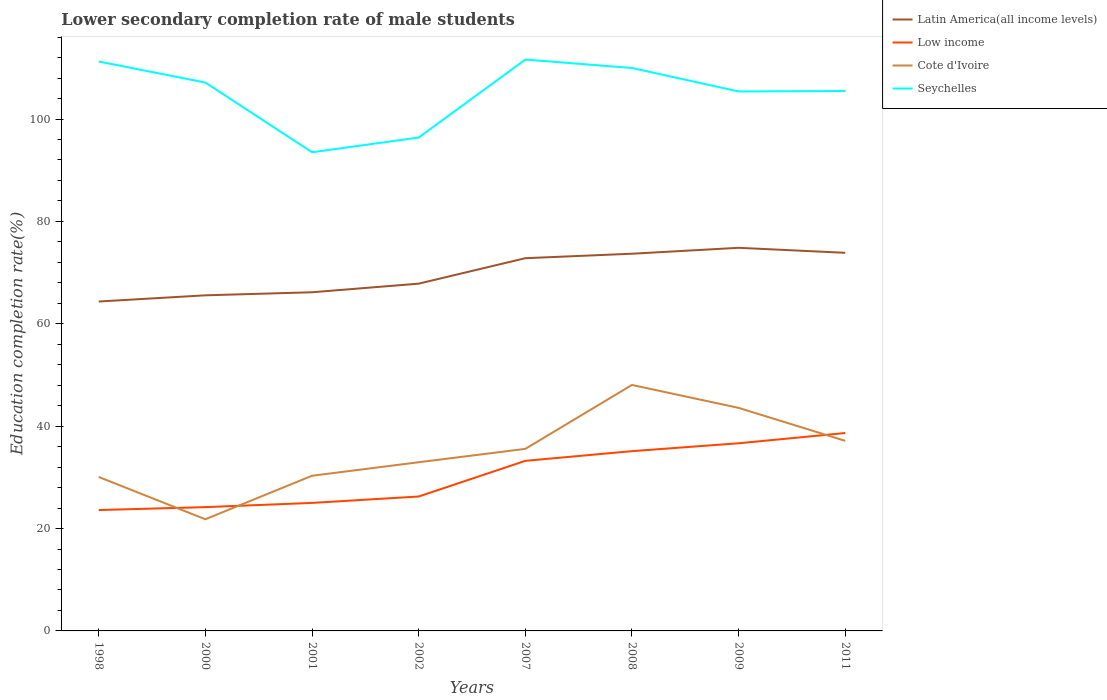How many different coloured lines are there?
Provide a succinct answer. 4. Does the line corresponding to Cote d'Ivoire intersect with the line corresponding to Low income?
Give a very brief answer. Yes. Across all years, what is the maximum lower secondary completion rate of male students in Low income?
Keep it short and to the point. 23.61. In which year was the lower secondary completion rate of male students in Low income maximum?
Your answer should be compact. 1998. What is the total lower secondary completion rate of male students in Low income in the graph?
Give a very brief answer. -6.97. What is the difference between the highest and the second highest lower secondary completion rate of male students in Seychelles?
Keep it short and to the point. 18.11. Where does the legend appear in the graph?
Your response must be concise. Top right. How many legend labels are there?
Offer a terse response. 4. How are the legend labels stacked?
Provide a succinct answer. Vertical. What is the title of the graph?
Ensure brevity in your answer.  Lower secondary completion rate of male students. What is the label or title of the Y-axis?
Ensure brevity in your answer.  Education completion rate(%). What is the Education completion rate(%) in Latin America(all income levels) in 1998?
Offer a terse response. 64.35. What is the Education completion rate(%) in Low income in 1998?
Your answer should be compact. 23.61. What is the Education completion rate(%) of Cote d'Ivoire in 1998?
Your response must be concise. 30.08. What is the Education completion rate(%) in Seychelles in 1998?
Offer a very short reply. 111.24. What is the Education completion rate(%) of Latin America(all income levels) in 2000?
Offer a very short reply. 65.56. What is the Education completion rate(%) of Low income in 2000?
Offer a very short reply. 24.18. What is the Education completion rate(%) in Cote d'Ivoire in 2000?
Offer a terse response. 21.82. What is the Education completion rate(%) of Seychelles in 2000?
Make the answer very short. 107.12. What is the Education completion rate(%) in Latin America(all income levels) in 2001?
Give a very brief answer. 66.16. What is the Education completion rate(%) in Low income in 2001?
Keep it short and to the point. 25.01. What is the Education completion rate(%) in Cote d'Ivoire in 2001?
Offer a terse response. 30.31. What is the Education completion rate(%) in Seychelles in 2001?
Make the answer very short. 93.51. What is the Education completion rate(%) of Latin America(all income levels) in 2002?
Make the answer very short. 67.84. What is the Education completion rate(%) in Low income in 2002?
Make the answer very short. 26.26. What is the Education completion rate(%) of Cote d'Ivoire in 2002?
Give a very brief answer. 32.95. What is the Education completion rate(%) in Seychelles in 2002?
Offer a terse response. 96.39. What is the Education completion rate(%) of Latin America(all income levels) in 2007?
Provide a short and direct response. 72.81. What is the Education completion rate(%) of Low income in 2007?
Offer a terse response. 33.23. What is the Education completion rate(%) of Cote d'Ivoire in 2007?
Your answer should be very brief. 35.57. What is the Education completion rate(%) in Seychelles in 2007?
Your answer should be compact. 111.62. What is the Education completion rate(%) of Latin America(all income levels) in 2008?
Provide a succinct answer. 73.69. What is the Education completion rate(%) in Low income in 2008?
Ensure brevity in your answer.  35.12. What is the Education completion rate(%) of Cote d'Ivoire in 2008?
Your answer should be compact. 48.05. What is the Education completion rate(%) in Seychelles in 2008?
Ensure brevity in your answer.  109.97. What is the Education completion rate(%) of Latin America(all income levels) in 2009?
Keep it short and to the point. 74.85. What is the Education completion rate(%) of Low income in 2009?
Ensure brevity in your answer.  36.66. What is the Education completion rate(%) in Cote d'Ivoire in 2009?
Make the answer very short. 43.58. What is the Education completion rate(%) in Seychelles in 2009?
Your answer should be very brief. 105.39. What is the Education completion rate(%) of Latin America(all income levels) in 2011?
Provide a short and direct response. 73.87. What is the Education completion rate(%) in Low income in 2011?
Make the answer very short. 38.66. What is the Education completion rate(%) of Cote d'Ivoire in 2011?
Provide a short and direct response. 37.13. What is the Education completion rate(%) of Seychelles in 2011?
Your answer should be compact. 105.48. Across all years, what is the maximum Education completion rate(%) in Latin America(all income levels)?
Give a very brief answer. 74.85. Across all years, what is the maximum Education completion rate(%) in Low income?
Make the answer very short. 38.66. Across all years, what is the maximum Education completion rate(%) in Cote d'Ivoire?
Offer a terse response. 48.05. Across all years, what is the maximum Education completion rate(%) in Seychelles?
Ensure brevity in your answer.  111.62. Across all years, what is the minimum Education completion rate(%) in Latin America(all income levels)?
Provide a short and direct response. 64.35. Across all years, what is the minimum Education completion rate(%) of Low income?
Ensure brevity in your answer.  23.61. Across all years, what is the minimum Education completion rate(%) in Cote d'Ivoire?
Provide a short and direct response. 21.82. Across all years, what is the minimum Education completion rate(%) of Seychelles?
Your answer should be compact. 93.51. What is the total Education completion rate(%) in Latin America(all income levels) in the graph?
Provide a short and direct response. 559.14. What is the total Education completion rate(%) of Low income in the graph?
Your answer should be compact. 242.74. What is the total Education completion rate(%) of Cote d'Ivoire in the graph?
Make the answer very short. 279.49. What is the total Education completion rate(%) of Seychelles in the graph?
Keep it short and to the point. 840.73. What is the difference between the Education completion rate(%) in Latin America(all income levels) in 1998 and that in 2000?
Provide a succinct answer. -1.21. What is the difference between the Education completion rate(%) in Low income in 1998 and that in 2000?
Your answer should be very brief. -0.57. What is the difference between the Education completion rate(%) in Cote d'Ivoire in 1998 and that in 2000?
Ensure brevity in your answer.  8.26. What is the difference between the Education completion rate(%) in Seychelles in 1998 and that in 2000?
Your answer should be compact. 4.12. What is the difference between the Education completion rate(%) in Latin America(all income levels) in 1998 and that in 2001?
Your answer should be compact. -1.81. What is the difference between the Education completion rate(%) in Low income in 1998 and that in 2001?
Keep it short and to the point. -1.4. What is the difference between the Education completion rate(%) in Cote d'Ivoire in 1998 and that in 2001?
Offer a very short reply. -0.24. What is the difference between the Education completion rate(%) of Seychelles in 1998 and that in 2001?
Your answer should be compact. 17.73. What is the difference between the Education completion rate(%) in Latin America(all income levels) in 1998 and that in 2002?
Give a very brief answer. -3.49. What is the difference between the Education completion rate(%) in Low income in 1998 and that in 2002?
Your answer should be compact. -2.64. What is the difference between the Education completion rate(%) of Cote d'Ivoire in 1998 and that in 2002?
Ensure brevity in your answer.  -2.88. What is the difference between the Education completion rate(%) of Seychelles in 1998 and that in 2002?
Make the answer very short. 14.85. What is the difference between the Education completion rate(%) in Latin America(all income levels) in 1998 and that in 2007?
Offer a very short reply. -8.46. What is the difference between the Education completion rate(%) of Low income in 1998 and that in 2007?
Provide a short and direct response. -9.61. What is the difference between the Education completion rate(%) of Cote d'Ivoire in 1998 and that in 2007?
Make the answer very short. -5.49. What is the difference between the Education completion rate(%) in Seychelles in 1998 and that in 2007?
Your response must be concise. -0.38. What is the difference between the Education completion rate(%) in Latin America(all income levels) in 1998 and that in 2008?
Your response must be concise. -9.34. What is the difference between the Education completion rate(%) of Low income in 1998 and that in 2008?
Keep it short and to the point. -11.5. What is the difference between the Education completion rate(%) in Cote d'Ivoire in 1998 and that in 2008?
Provide a succinct answer. -17.97. What is the difference between the Education completion rate(%) in Seychelles in 1998 and that in 2008?
Make the answer very short. 1.27. What is the difference between the Education completion rate(%) in Latin America(all income levels) in 1998 and that in 2009?
Offer a terse response. -10.49. What is the difference between the Education completion rate(%) of Low income in 1998 and that in 2009?
Ensure brevity in your answer.  -13.05. What is the difference between the Education completion rate(%) in Cote d'Ivoire in 1998 and that in 2009?
Your answer should be very brief. -13.5. What is the difference between the Education completion rate(%) in Seychelles in 1998 and that in 2009?
Provide a succinct answer. 5.85. What is the difference between the Education completion rate(%) of Latin America(all income levels) in 1998 and that in 2011?
Provide a short and direct response. -9.51. What is the difference between the Education completion rate(%) in Low income in 1998 and that in 2011?
Give a very brief answer. -15.05. What is the difference between the Education completion rate(%) of Cote d'Ivoire in 1998 and that in 2011?
Provide a succinct answer. -7.05. What is the difference between the Education completion rate(%) of Seychelles in 1998 and that in 2011?
Your response must be concise. 5.76. What is the difference between the Education completion rate(%) of Latin America(all income levels) in 2000 and that in 2001?
Provide a succinct answer. -0.6. What is the difference between the Education completion rate(%) in Low income in 2000 and that in 2001?
Your response must be concise. -0.83. What is the difference between the Education completion rate(%) in Cote d'Ivoire in 2000 and that in 2001?
Give a very brief answer. -8.5. What is the difference between the Education completion rate(%) of Seychelles in 2000 and that in 2001?
Offer a terse response. 13.61. What is the difference between the Education completion rate(%) of Latin America(all income levels) in 2000 and that in 2002?
Your response must be concise. -2.28. What is the difference between the Education completion rate(%) in Low income in 2000 and that in 2002?
Provide a succinct answer. -2.07. What is the difference between the Education completion rate(%) in Cote d'Ivoire in 2000 and that in 2002?
Keep it short and to the point. -11.14. What is the difference between the Education completion rate(%) of Seychelles in 2000 and that in 2002?
Your answer should be compact. 10.73. What is the difference between the Education completion rate(%) in Latin America(all income levels) in 2000 and that in 2007?
Give a very brief answer. -7.25. What is the difference between the Education completion rate(%) in Low income in 2000 and that in 2007?
Keep it short and to the point. -9.04. What is the difference between the Education completion rate(%) in Cote d'Ivoire in 2000 and that in 2007?
Your answer should be compact. -13.75. What is the difference between the Education completion rate(%) of Seychelles in 2000 and that in 2007?
Your answer should be compact. -4.5. What is the difference between the Education completion rate(%) of Latin America(all income levels) in 2000 and that in 2008?
Your answer should be very brief. -8.13. What is the difference between the Education completion rate(%) of Low income in 2000 and that in 2008?
Offer a very short reply. -10.93. What is the difference between the Education completion rate(%) in Cote d'Ivoire in 2000 and that in 2008?
Offer a very short reply. -26.24. What is the difference between the Education completion rate(%) of Seychelles in 2000 and that in 2008?
Your response must be concise. -2.85. What is the difference between the Education completion rate(%) of Latin America(all income levels) in 2000 and that in 2009?
Provide a short and direct response. -9.28. What is the difference between the Education completion rate(%) of Low income in 2000 and that in 2009?
Give a very brief answer. -12.48. What is the difference between the Education completion rate(%) of Cote d'Ivoire in 2000 and that in 2009?
Keep it short and to the point. -21.76. What is the difference between the Education completion rate(%) of Seychelles in 2000 and that in 2009?
Give a very brief answer. 1.73. What is the difference between the Education completion rate(%) of Latin America(all income levels) in 2000 and that in 2011?
Your answer should be compact. -8.3. What is the difference between the Education completion rate(%) of Low income in 2000 and that in 2011?
Give a very brief answer. -14.48. What is the difference between the Education completion rate(%) of Cote d'Ivoire in 2000 and that in 2011?
Offer a terse response. -15.32. What is the difference between the Education completion rate(%) of Seychelles in 2000 and that in 2011?
Provide a short and direct response. 1.65. What is the difference between the Education completion rate(%) in Latin America(all income levels) in 2001 and that in 2002?
Your answer should be very brief. -1.68. What is the difference between the Education completion rate(%) of Low income in 2001 and that in 2002?
Give a very brief answer. -1.25. What is the difference between the Education completion rate(%) of Cote d'Ivoire in 2001 and that in 2002?
Provide a succinct answer. -2.64. What is the difference between the Education completion rate(%) in Seychelles in 2001 and that in 2002?
Offer a terse response. -2.88. What is the difference between the Education completion rate(%) in Latin America(all income levels) in 2001 and that in 2007?
Your response must be concise. -6.66. What is the difference between the Education completion rate(%) of Low income in 2001 and that in 2007?
Your answer should be compact. -8.22. What is the difference between the Education completion rate(%) of Cote d'Ivoire in 2001 and that in 2007?
Provide a short and direct response. -5.25. What is the difference between the Education completion rate(%) in Seychelles in 2001 and that in 2007?
Make the answer very short. -18.11. What is the difference between the Education completion rate(%) in Latin America(all income levels) in 2001 and that in 2008?
Make the answer very short. -7.53. What is the difference between the Education completion rate(%) of Low income in 2001 and that in 2008?
Provide a short and direct response. -10.11. What is the difference between the Education completion rate(%) of Cote d'Ivoire in 2001 and that in 2008?
Offer a terse response. -17.74. What is the difference between the Education completion rate(%) in Seychelles in 2001 and that in 2008?
Give a very brief answer. -16.46. What is the difference between the Education completion rate(%) of Latin America(all income levels) in 2001 and that in 2009?
Offer a very short reply. -8.69. What is the difference between the Education completion rate(%) of Low income in 2001 and that in 2009?
Keep it short and to the point. -11.65. What is the difference between the Education completion rate(%) in Cote d'Ivoire in 2001 and that in 2009?
Ensure brevity in your answer.  -13.26. What is the difference between the Education completion rate(%) of Seychelles in 2001 and that in 2009?
Give a very brief answer. -11.88. What is the difference between the Education completion rate(%) in Latin America(all income levels) in 2001 and that in 2011?
Offer a terse response. -7.71. What is the difference between the Education completion rate(%) in Low income in 2001 and that in 2011?
Ensure brevity in your answer.  -13.65. What is the difference between the Education completion rate(%) of Cote d'Ivoire in 2001 and that in 2011?
Give a very brief answer. -6.82. What is the difference between the Education completion rate(%) of Seychelles in 2001 and that in 2011?
Give a very brief answer. -11.97. What is the difference between the Education completion rate(%) in Latin America(all income levels) in 2002 and that in 2007?
Ensure brevity in your answer.  -4.97. What is the difference between the Education completion rate(%) in Low income in 2002 and that in 2007?
Offer a terse response. -6.97. What is the difference between the Education completion rate(%) of Cote d'Ivoire in 2002 and that in 2007?
Keep it short and to the point. -2.61. What is the difference between the Education completion rate(%) of Seychelles in 2002 and that in 2007?
Provide a succinct answer. -15.23. What is the difference between the Education completion rate(%) in Latin America(all income levels) in 2002 and that in 2008?
Offer a terse response. -5.85. What is the difference between the Education completion rate(%) in Low income in 2002 and that in 2008?
Provide a short and direct response. -8.86. What is the difference between the Education completion rate(%) of Cote d'Ivoire in 2002 and that in 2008?
Your answer should be very brief. -15.1. What is the difference between the Education completion rate(%) of Seychelles in 2002 and that in 2008?
Provide a short and direct response. -13.58. What is the difference between the Education completion rate(%) in Latin America(all income levels) in 2002 and that in 2009?
Offer a very short reply. -7. What is the difference between the Education completion rate(%) of Low income in 2002 and that in 2009?
Your answer should be compact. -10.4. What is the difference between the Education completion rate(%) in Cote d'Ivoire in 2002 and that in 2009?
Ensure brevity in your answer.  -10.62. What is the difference between the Education completion rate(%) in Seychelles in 2002 and that in 2009?
Offer a terse response. -9. What is the difference between the Education completion rate(%) of Latin America(all income levels) in 2002 and that in 2011?
Provide a short and direct response. -6.02. What is the difference between the Education completion rate(%) of Low income in 2002 and that in 2011?
Ensure brevity in your answer.  -12.4. What is the difference between the Education completion rate(%) of Cote d'Ivoire in 2002 and that in 2011?
Give a very brief answer. -4.18. What is the difference between the Education completion rate(%) in Seychelles in 2002 and that in 2011?
Keep it short and to the point. -9.09. What is the difference between the Education completion rate(%) of Latin America(all income levels) in 2007 and that in 2008?
Your answer should be very brief. -0.88. What is the difference between the Education completion rate(%) of Low income in 2007 and that in 2008?
Your answer should be compact. -1.89. What is the difference between the Education completion rate(%) of Cote d'Ivoire in 2007 and that in 2008?
Your response must be concise. -12.48. What is the difference between the Education completion rate(%) in Seychelles in 2007 and that in 2008?
Offer a terse response. 1.65. What is the difference between the Education completion rate(%) of Latin America(all income levels) in 2007 and that in 2009?
Provide a short and direct response. -2.03. What is the difference between the Education completion rate(%) of Low income in 2007 and that in 2009?
Make the answer very short. -3.43. What is the difference between the Education completion rate(%) in Cote d'Ivoire in 2007 and that in 2009?
Make the answer very short. -8.01. What is the difference between the Education completion rate(%) of Seychelles in 2007 and that in 2009?
Make the answer very short. 6.23. What is the difference between the Education completion rate(%) of Latin America(all income levels) in 2007 and that in 2011?
Provide a short and direct response. -1.05. What is the difference between the Education completion rate(%) in Low income in 2007 and that in 2011?
Your answer should be compact. -5.43. What is the difference between the Education completion rate(%) of Cote d'Ivoire in 2007 and that in 2011?
Give a very brief answer. -1.56. What is the difference between the Education completion rate(%) of Seychelles in 2007 and that in 2011?
Give a very brief answer. 6.14. What is the difference between the Education completion rate(%) of Latin America(all income levels) in 2008 and that in 2009?
Ensure brevity in your answer.  -1.16. What is the difference between the Education completion rate(%) in Low income in 2008 and that in 2009?
Provide a succinct answer. -1.54. What is the difference between the Education completion rate(%) of Cote d'Ivoire in 2008 and that in 2009?
Make the answer very short. 4.48. What is the difference between the Education completion rate(%) in Seychelles in 2008 and that in 2009?
Give a very brief answer. 4.58. What is the difference between the Education completion rate(%) of Latin America(all income levels) in 2008 and that in 2011?
Your answer should be compact. -0.18. What is the difference between the Education completion rate(%) of Low income in 2008 and that in 2011?
Offer a very short reply. -3.54. What is the difference between the Education completion rate(%) of Cote d'Ivoire in 2008 and that in 2011?
Provide a short and direct response. 10.92. What is the difference between the Education completion rate(%) in Seychelles in 2008 and that in 2011?
Provide a short and direct response. 4.49. What is the difference between the Education completion rate(%) of Latin America(all income levels) in 2009 and that in 2011?
Offer a very short reply. 0.98. What is the difference between the Education completion rate(%) of Low income in 2009 and that in 2011?
Provide a short and direct response. -2. What is the difference between the Education completion rate(%) of Cote d'Ivoire in 2009 and that in 2011?
Your answer should be very brief. 6.44. What is the difference between the Education completion rate(%) of Seychelles in 2009 and that in 2011?
Offer a very short reply. -0.09. What is the difference between the Education completion rate(%) in Latin America(all income levels) in 1998 and the Education completion rate(%) in Low income in 2000?
Keep it short and to the point. 40.17. What is the difference between the Education completion rate(%) of Latin America(all income levels) in 1998 and the Education completion rate(%) of Cote d'Ivoire in 2000?
Give a very brief answer. 42.54. What is the difference between the Education completion rate(%) in Latin America(all income levels) in 1998 and the Education completion rate(%) in Seychelles in 2000?
Make the answer very short. -42.77. What is the difference between the Education completion rate(%) in Low income in 1998 and the Education completion rate(%) in Cote d'Ivoire in 2000?
Provide a short and direct response. 1.8. What is the difference between the Education completion rate(%) of Low income in 1998 and the Education completion rate(%) of Seychelles in 2000?
Offer a very short reply. -83.51. What is the difference between the Education completion rate(%) in Cote d'Ivoire in 1998 and the Education completion rate(%) in Seychelles in 2000?
Give a very brief answer. -77.05. What is the difference between the Education completion rate(%) in Latin America(all income levels) in 1998 and the Education completion rate(%) in Low income in 2001?
Give a very brief answer. 39.34. What is the difference between the Education completion rate(%) in Latin America(all income levels) in 1998 and the Education completion rate(%) in Cote d'Ivoire in 2001?
Give a very brief answer. 34.04. What is the difference between the Education completion rate(%) in Latin America(all income levels) in 1998 and the Education completion rate(%) in Seychelles in 2001?
Provide a short and direct response. -29.16. What is the difference between the Education completion rate(%) in Low income in 1998 and the Education completion rate(%) in Cote d'Ivoire in 2001?
Ensure brevity in your answer.  -6.7. What is the difference between the Education completion rate(%) in Low income in 1998 and the Education completion rate(%) in Seychelles in 2001?
Your answer should be compact. -69.9. What is the difference between the Education completion rate(%) of Cote d'Ivoire in 1998 and the Education completion rate(%) of Seychelles in 2001?
Provide a succinct answer. -63.43. What is the difference between the Education completion rate(%) of Latin America(all income levels) in 1998 and the Education completion rate(%) of Low income in 2002?
Offer a very short reply. 38.1. What is the difference between the Education completion rate(%) in Latin America(all income levels) in 1998 and the Education completion rate(%) in Cote d'Ivoire in 2002?
Provide a short and direct response. 31.4. What is the difference between the Education completion rate(%) in Latin America(all income levels) in 1998 and the Education completion rate(%) in Seychelles in 2002?
Your answer should be very brief. -32.04. What is the difference between the Education completion rate(%) in Low income in 1998 and the Education completion rate(%) in Cote d'Ivoire in 2002?
Keep it short and to the point. -9.34. What is the difference between the Education completion rate(%) in Low income in 1998 and the Education completion rate(%) in Seychelles in 2002?
Offer a very short reply. -72.78. What is the difference between the Education completion rate(%) of Cote d'Ivoire in 1998 and the Education completion rate(%) of Seychelles in 2002?
Your answer should be very brief. -66.31. What is the difference between the Education completion rate(%) in Latin America(all income levels) in 1998 and the Education completion rate(%) in Low income in 2007?
Offer a terse response. 31.13. What is the difference between the Education completion rate(%) in Latin America(all income levels) in 1998 and the Education completion rate(%) in Cote d'Ivoire in 2007?
Your answer should be very brief. 28.79. What is the difference between the Education completion rate(%) of Latin America(all income levels) in 1998 and the Education completion rate(%) of Seychelles in 2007?
Offer a terse response. -47.27. What is the difference between the Education completion rate(%) in Low income in 1998 and the Education completion rate(%) in Cote d'Ivoire in 2007?
Provide a short and direct response. -11.95. What is the difference between the Education completion rate(%) in Low income in 1998 and the Education completion rate(%) in Seychelles in 2007?
Your answer should be very brief. -88.01. What is the difference between the Education completion rate(%) of Cote d'Ivoire in 1998 and the Education completion rate(%) of Seychelles in 2007?
Offer a very short reply. -81.54. What is the difference between the Education completion rate(%) of Latin America(all income levels) in 1998 and the Education completion rate(%) of Low income in 2008?
Provide a short and direct response. 29.24. What is the difference between the Education completion rate(%) of Latin America(all income levels) in 1998 and the Education completion rate(%) of Cote d'Ivoire in 2008?
Provide a succinct answer. 16.3. What is the difference between the Education completion rate(%) of Latin America(all income levels) in 1998 and the Education completion rate(%) of Seychelles in 2008?
Your response must be concise. -45.62. What is the difference between the Education completion rate(%) in Low income in 1998 and the Education completion rate(%) in Cote d'Ivoire in 2008?
Your answer should be compact. -24.44. What is the difference between the Education completion rate(%) of Low income in 1998 and the Education completion rate(%) of Seychelles in 2008?
Offer a terse response. -86.36. What is the difference between the Education completion rate(%) in Cote d'Ivoire in 1998 and the Education completion rate(%) in Seychelles in 2008?
Your answer should be very brief. -79.89. What is the difference between the Education completion rate(%) in Latin America(all income levels) in 1998 and the Education completion rate(%) in Low income in 2009?
Offer a very short reply. 27.69. What is the difference between the Education completion rate(%) of Latin America(all income levels) in 1998 and the Education completion rate(%) of Cote d'Ivoire in 2009?
Give a very brief answer. 20.78. What is the difference between the Education completion rate(%) of Latin America(all income levels) in 1998 and the Education completion rate(%) of Seychelles in 2009?
Keep it short and to the point. -41.04. What is the difference between the Education completion rate(%) of Low income in 1998 and the Education completion rate(%) of Cote d'Ivoire in 2009?
Provide a short and direct response. -19.96. What is the difference between the Education completion rate(%) in Low income in 1998 and the Education completion rate(%) in Seychelles in 2009?
Ensure brevity in your answer.  -81.78. What is the difference between the Education completion rate(%) of Cote d'Ivoire in 1998 and the Education completion rate(%) of Seychelles in 2009?
Offer a terse response. -75.31. What is the difference between the Education completion rate(%) in Latin America(all income levels) in 1998 and the Education completion rate(%) in Low income in 2011?
Provide a short and direct response. 25.69. What is the difference between the Education completion rate(%) in Latin America(all income levels) in 1998 and the Education completion rate(%) in Cote d'Ivoire in 2011?
Your answer should be compact. 27.22. What is the difference between the Education completion rate(%) of Latin America(all income levels) in 1998 and the Education completion rate(%) of Seychelles in 2011?
Provide a succinct answer. -41.13. What is the difference between the Education completion rate(%) of Low income in 1998 and the Education completion rate(%) of Cote d'Ivoire in 2011?
Offer a very short reply. -13.52. What is the difference between the Education completion rate(%) in Low income in 1998 and the Education completion rate(%) in Seychelles in 2011?
Make the answer very short. -81.86. What is the difference between the Education completion rate(%) in Cote d'Ivoire in 1998 and the Education completion rate(%) in Seychelles in 2011?
Ensure brevity in your answer.  -75.4. What is the difference between the Education completion rate(%) of Latin America(all income levels) in 2000 and the Education completion rate(%) of Low income in 2001?
Your answer should be compact. 40.55. What is the difference between the Education completion rate(%) of Latin America(all income levels) in 2000 and the Education completion rate(%) of Cote d'Ivoire in 2001?
Provide a short and direct response. 35.25. What is the difference between the Education completion rate(%) in Latin America(all income levels) in 2000 and the Education completion rate(%) in Seychelles in 2001?
Your answer should be very brief. -27.95. What is the difference between the Education completion rate(%) of Low income in 2000 and the Education completion rate(%) of Cote d'Ivoire in 2001?
Your answer should be very brief. -6.13. What is the difference between the Education completion rate(%) in Low income in 2000 and the Education completion rate(%) in Seychelles in 2001?
Provide a short and direct response. -69.33. What is the difference between the Education completion rate(%) of Cote d'Ivoire in 2000 and the Education completion rate(%) of Seychelles in 2001?
Your answer should be very brief. -71.7. What is the difference between the Education completion rate(%) of Latin America(all income levels) in 2000 and the Education completion rate(%) of Low income in 2002?
Keep it short and to the point. 39.31. What is the difference between the Education completion rate(%) in Latin America(all income levels) in 2000 and the Education completion rate(%) in Cote d'Ivoire in 2002?
Provide a short and direct response. 32.61. What is the difference between the Education completion rate(%) in Latin America(all income levels) in 2000 and the Education completion rate(%) in Seychelles in 2002?
Provide a succinct answer. -30.83. What is the difference between the Education completion rate(%) in Low income in 2000 and the Education completion rate(%) in Cote d'Ivoire in 2002?
Give a very brief answer. -8.77. What is the difference between the Education completion rate(%) of Low income in 2000 and the Education completion rate(%) of Seychelles in 2002?
Offer a very short reply. -72.21. What is the difference between the Education completion rate(%) in Cote d'Ivoire in 2000 and the Education completion rate(%) in Seychelles in 2002?
Provide a succinct answer. -74.58. What is the difference between the Education completion rate(%) of Latin America(all income levels) in 2000 and the Education completion rate(%) of Low income in 2007?
Make the answer very short. 32.33. What is the difference between the Education completion rate(%) of Latin America(all income levels) in 2000 and the Education completion rate(%) of Cote d'Ivoire in 2007?
Offer a very short reply. 30. What is the difference between the Education completion rate(%) of Latin America(all income levels) in 2000 and the Education completion rate(%) of Seychelles in 2007?
Ensure brevity in your answer.  -46.06. What is the difference between the Education completion rate(%) of Low income in 2000 and the Education completion rate(%) of Cote d'Ivoire in 2007?
Keep it short and to the point. -11.38. What is the difference between the Education completion rate(%) of Low income in 2000 and the Education completion rate(%) of Seychelles in 2007?
Your answer should be compact. -87.44. What is the difference between the Education completion rate(%) of Cote d'Ivoire in 2000 and the Education completion rate(%) of Seychelles in 2007?
Keep it short and to the point. -89.81. What is the difference between the Education completion rate(%) of Latin America(all income levels) in 2000 and the Education completion rate(%) of Low income in 2008?
Offer a terse response. 30.44. What is the difference between the Education completion rate(%) of Latin America(all income levels) in 2000 and the Education completion rate(%) of Cote d'Ivoire in 2008?
Make the answer very short. 17.51. What is the difference between the Education completion rate(%) in Latin America(all income levels) in 2000 and the Education completion rate(%) in Seychelles in 2008?
Your answer should be very brief. -44.41. What is the difference between the Education completion rate(%) of Low income in 2000 and the Education completion rate(%) of Cote d'Ivoire in 2008?
Provide a short and direct response. -23.87. What is the difference between the Education completion rate(%) in Low income in 2000 and the Education completion rate(%) in Seychelles in 2008?
Provide a short and direct response. -85.79. What is the difference between the Education completion rate(%) of Cote d'Ivoire in 2000 and the Education completion rate(%) of Seychelles in 2008?
Ensure brevity in your answer.  -88.16. What is the difference between the Education completion rate(%) of Latin America(all income levels) in 2000 and the Education completion rate(%) of Low income in 2009?
Give a very brief answer. 28.9. What is the difference between the Education completion rate(%) of Latin America(all income levels) in 2000 and the Education completion rate(%) of Cote d'Ivoire in 2009?
Ensure brevity in your answer.  21.99. What is the difference between the Education completion rate(%) in Latin America(all income levels) in 2000 and the Education completion rate(%) in Seychelles in 2009?
Provide a short and direct response. -39.83. What is the difference between the Education completion rate(%) in Low income in 2000 and the Education completion rate(%) in Cote d'Ivoire in 2009?
Make the answer very short. -19.39. What is the difference between the Education completion rate(%) in Low income in 2000 and the Education completion rate(%) in Seychelles in 2009?
Keep it short and to the point. -81.21. What is the difference between the Education completion rate(%) of Cote d'Ivoire in 2000 and the Education completion rate(%) of Seychelles in 2009?
Give a very brief answer. -83.57. What is the difference between the Education completion rate(%) of Latin America(all income levels) in 2000 and the Education completion rate(%) of Low income in 2011?
Your response must be concise. 26.9. What is the difference between the Education completion rate(%) of Latin America(all income levels) in 2000 and the Education completion rate(%) of Cote d'Ivoire in 2011?
Offer a terse response. 28.43. What is the difference between the Education completion rate(%) in Latin America(all income levels) in 2000 and the Education completion rate(%) in Seychelles in 2011?
Give a very brief answer. -39.92. What is the difference between the Education completion rate(%) of Low income in 2000 and the Education completion rate(%) of Cote d'Ivoire in 2011?
Your answer should be compact. -12.95. What is the difference between the Education completion rate(%) of Low income in 2000 and the Education completion rate(%) of Seychelles in 2011?
Your answer should be very brief. -81.3. What is the difference between the Education completion rate(%) of Cote d'Ivoire in 2000 and the Education completion rate(%) of Seychelles in 2011?
Provide a succinct answer. -83.66. What is the difference between the Education completion rate(%) of Latin America(all income levels) in 2001 and the Education completion rate(%) of Low income in 2002?
Your answer should be very brief. 39.9. What is the difference between the Education completion rate(%) in Latin America(all income levels) in 2001 and the Education completion rate(%) in Cote d'Ivoire in 2002?
Your answer should be compact. 33.21. What is the difference between the Education completion rate(%) of Latin America(all income levels) in 2001 and the Education completion rate(%) of Seychelles in 2002?
Your response must be concise. -30.23. What is the difference between the Education completion rate(%) of Low income in 2001 and the Education completion rate(%) of Cote d'Ivoire in 2002?
Make the answer very short. -7.94. What is the difference between the Education completion rate(%) of Low income in 2001 and the Education completion rate(%) of Seychelles in 2002?
Make the answer very short. -71.38. What is the difference between the Education completion rate(%) in Cote d'Ivoire in 2001 and the Education completion rate(%) in Seychelles in 2002?
Provide a succinct answer. -66.08. What is the difference between the Education completion rate(%) of Latin America(all income levels) in 2001 and the Education completion rate(%) of Low income in 2007?
Your answer should be very brief. 32.93. What is the difference between the Education completion rate(%) in Latin America(all income levels) in 2001 and the Education completion rate(%) in Cote d'Ivoire in 2007?
Give a very brief answer. 30.59. What is the difference between the Education completion rate(%) in Latin America(all income levels) in 2001 and the Education completion rate(%) in Seychelles in 2007?
Give a very brief answer. -45.46. What is the difference between the Education completion rate(%) of Low income in 2001 and the Education completion rate(%) of Cote d'Ivoire in 2007?
Offer a very short reply. -10.56. What is the difference between the Education completion rate(%) in Low income in 2001 and the Education completion rate(%) in Seychelles in 2007?
Provide a short and direct response. -86.61. What is the difference between the Education completion rate(%) of Cote d'Ivoire in 2001 and the Education completion rate(%) of Seychelles in 2007?
Give a very brief answer. -81.31. What is the difference between the Education completion rate(%) in Latin America(all income levels) in 2001 and the Education completion rate(%) in Low income in 2008?
Ensure brevity in your answer.  31.04. What is the difference between the Education completion rate(%) in Latin America(all income levels) in 2001 and the Education completion rate(%) in Cote d'Ivoire in 2008?
Provide a short and direct response. 18.11. What is the difference between the Education completion rate(%) of Latin America(all income levels) in 2001 and the Education completion rate(%) of Seychelles in 2008?
Your answer should be very brief. -43.81. What is the difference between the Education completion rate(%) of Low income in 2001 and the Education completion rate(%) of Cote d'Ivoire in 2008?
Give a very brief answer. -23.04. What is the difference between the Education completion rate(%) of Low income in 2001 and the Education completion rate(%) of Seychelles in 2008?
Give a very brief answer. -84.96. What is the difference between the Education completion rate(%) of Cote d'Ivoire in 2001 and the Education completion rate(%) of Seychelles in 2008?
Provide a succinct answer. -79.66. What is the difference between the Education completion rate(%) of Latin America(all income levels) in 2001 and the Education completion rate(%) of Low income in 2009?
Your answer should be compact. 29.5. What is the difference between the Education completion rate(%) in Latin America(all income levels) in 2001 and the Education completion rate(%) in Cote d'Ivoire in 2009?
Offer a very short reply. 22.58. What is the difference between the Education completion rate(%) of Latin America(all income levels) in 2001 and the Education completion rate(%) of Seychelles in 2009?
Make the answer very short. -39.23. What is the difference between the Education completion rate(%) of Low income in 2001 and the Education completion rate(%) of Cote d'Ivoire in 2009?
Your response must be concise. -18.57. What is the difference between the Education completion rate(%) in Low income in 2001 and the Education completion rate(%) in Seychelles in 2009?
Make the answer very short. -80.38. What is the difference between the Education completion rate(%) of Cote d'Ivoire in 2001 and the Education completion rate(%) of Seychelles in 2009?
Make the answer very short. -75.08. What is the difference between the Education completion rate(%) of Latin America(all income levels) in 2001 and the Education completion rate(%) of Low income in 2011?
Give a very brief answer. 27.5. What is the difference between the Education completion rate(%) of Latin America(all income levels) in 2001 and the Education completion rate(%) of Cote d'Ivoire in 2011?
Provide a succinct answer. 29.03. What is the difference between the Education completion rate(%) in Latin America(all income levels) in 2001 and the Education completion rate(%) in Seychelles in 2011?
Offer a very short reply. -39.32. What is the difference between the Education completion rate(%) in Low income in 2001 and the Education completion rate(%) in Cote d'Ivoire in 2011?
Provide a succinct answer. -12.12. What is the difference between the Education completion rate(%) in Low income in 2001 and the Education completion rate(%) in Seychelles in 2011?
Provide a short and direct response. -80.47. What is the difference between the Education completion rate(%) of Cote d'Ivoire in 2001 and the Education completion rate(%) of Seychelles in 2011?
Your response must be concise. -75.17. What is the difference between the Education completion rate(%) in Latin America(all income levels) in 2002 and the Education completion rate(%) in Low income in 2007?
Offer a very short reply. 34.61. What is the difference between the Education completion rate(%) in Latin America(all income levels) in 2002 and the Education completion rate(%) in Cote d'Ivoire in 2007?
Your answer should be very brief. 32.27. What is the difference between the Education completion rate(%) in Latin America(all income levels) in 2002 and the Education completion rate(%) in Seychelles in 2007?
Offer a terse response. -43.78. What is the difference between the Education completion rate(%) in Low income in 2002 and the Education completion rate(%) in Cote d'Ivoire in 2007?
Your response must be concise. -9.31. What is the difference between the Education completion rate(%) of Low income in 2002 and the Education completion rate(%) of Seychelles in 2007?
Provide a succinct answer. -85.36. What is the difference between the Education completion rate(%) in Cote d'Ivoire in 2002 and the Education completion rate(%) in Seychelles in 2007?
Your answer should be very brief. -78.67. What is the difference between the Education completion rate(%) in Latin America(all income levels) in 2002 and the Education completion rate(%) in Low income in 2008?
Give a very brief answer. 32.72. What is the difference between the Education completion rate(%) in Latin America(all income levels) in 2002 and the Education completion rate(%) in Cote d'Ivoire in 2008?
Keep it short and to the point. 19.79. What is the difference between the Education completion rate(%) in Latin America(all income levels) in 2002 and the Education completion rate(%) in Seychelles in 2008?
Make the answer very short. -42.13. What is the difference between the Education completion rate(%) of Low income in 2002 and the Education completion rate(%) of Cote d'Ivoire in 2008?
Your answer should be compact. -21.79. What is the difference between the Education completion rate(%) of Low income in 2002 and the Education completion rate(%) of Seychelles in 2008?
Offer a very short reply. -83.72. What is the difference between the Education completion rate(%) of Cote d'Ivoire in 2002 and the Education completion rate(%) of Seychelles in 2008?
Provide a short and direct response. -77.02. What is the difference between the Education completion rate(%) of Latin America(all income levels) in 2002 and the Education completion rate(%) of Low income in 2009?
Your answer should be compact. 31.18. What is the difference between the Education completion rate(%) of Latin America(all income levels) in 2002 and the Education completion rate(%) of Cote d'Ivoire in 2009?
Your response must be concise. 24.27. What is the difference between the Education completion rate(%) of Latin America(all income levels) in 2002 and the Education completion rate(%) of Seychelles in 2009?
Your answer should be very brief. -37.55. What is the difference between the Education completion rate(%) of Low income in 2002 and the Education completion rate(%) of Cote d'Ivoire in 2009?
Offer a very short reply. -17.32. What is the difference between the Education completion rate(%) of Low income in 2002 and the Education completion rate(%) of Seychelles in 2009?
Your response must be concise. -79.13. What is the difference between the Education completion rate(%) in Cote d'Ivoire in 2002 and the Education completion rate(%) in Seychelles in 2009?
Your answer should be compact. -72.44. What is the difference between the Education completion rate(%) of Latin America(all income levels) in 2002 and the Education completion rate(%) of Low income in 2011?
Provide a short and direct response. 29.18. What is the difference between the Education completion rate(%) in Latin America(all income levels) in 2002 and the Education completion rate(%) in Cote d'Ivoire in 2011?
Your response must be concise. 30.71. What is the difference between the Education completion rate(%) in Latin America(all income levels) in 2002 and the Education completion rate(%) in Seychelles in 2011?
Your answer should be compact. -37.64. What is the difference between the Education completion rate(%) in Low income in 2002 and the Education completion rate(%) in Cote d'Ivoire in 2011?
Keep it short and to the point. -10.88. What is the difference between the Education completion rate(%) of Low income in 2002 and the Education completion rate(%) of Seychelles in 2011?
Offer a very short reply. -79.22. What is the difference between the Education completion rate(%) of Cote d'Ivoire in 2002 and the Education completion rate(%) of Seychelles in 2011?
Offer a very short reply. -72.53. What is the difference between the Education completion rate(%) in Latin America(all income levels) in 2007 and the Education completion rate(%) in Low income in 2008?
Ensure brevity in your answer.  37.7. What is the difference between the Education completion rate(%) in Latin America(all income levels) in 2007 and the Education completion rate(%) in Cote d'Ivoire in 2008?
Ensure brevity in your answer.  24.76. What is the difference between the Education completion rate(%) of Latin America(all income levels) in 2007 and the Education completion rate(%) of Seychelles in 2008?
Your answer should be compact. -37.16. What is the difference between the Education completion rate(%) of Low income in 2007 and the Education completion rate(%) of Cote d'Ivoire in 2008?
Provide a short and direct response. -14.82. What is the difference between the Education completion rate(%) of Low income in 2007 and the Education completion rate(%) of Seychelles in 2008?
Offer a terse response. -76.74. What is the difference between the Education completion rate(%) of Cote d'Ivoire in 2007 and the Education completion rate(%) of Seychelles in 2008?
Provide a succinct answer. -74.41. What is the difference between the Education completion rate(%) in Latin America(all income levels) in 2007 and the Education completion rate(%) in Low income in 2009?
Offer a very short reply. 36.15. What is the difference between the Education completion rate(%) of Latin America(all income levels) in 2007 and the Education completion rate(%) of Cote d'Ivoire in 2009?
Give a very brief answer. 29.24. What is the difference between the Education completion rate(%) of Latin America(all income levels) in 2007 and the Education completion rate(%) of Seychelles in 2009?
Your answer should be very brief. -32.58. What is the difference between the Education completion rate(%) in Low income in 2007 and the Education completion rate(%) in Cote d'Ivoire in 2009?
Offer a very short reply. -10.35. What is the difference between the Education completion rate(%) in Low income in 2007 and the Education completion rate(%) in Seychelles in 2009?
Your answer should be compact. -72.16. What is the difference between the Education completion rate(%) in Cote d'Ivoire in 2007 and the Education completion rate(%) in Seychelles in 2009?
Your answer should be very brief. -69.82. What is the difference between the Education completion rate(%) in Latin America(all income levels) in 2007 and the Education completion rate(%) in Low income in 2011?
Ensure brevity in your answer.  34.15. What is the difference between the Education completion rate(%) of Latin America(all income levels) in 2007 and the Education completion rate(%) of Cote d'Ivoire in 2011?
Your answer should be compact. 35.68. What is the difference between the Education completion rate(%) in Latin America(all income levels) in 2007 and the Education completion rate(%) in Seychelles in 2011?
Provide a succinct answer. -32.66. What is the difference between the Education completion rate(%) in Low income in 2007 and the Education completion rate(%) in Cote d'Ivoire in 2011?
Your answer should be compact. -3.9. What is the difference between the Education completion rate(%) in Low income in 2007 and the Education completion rate(%) in Seychelles in 2011?
Keep it short and to the point. -72.25. What is the difference between the Education completion rate(%) of Cote d'Ivoire in 2007 and the Education completion rate(%) of Seychelles in 2011?
Provide a succinct answer. -69.91. What is the difference between the Education completion rate(%) in Latin America(all income levels) in 2008 and the Education completion rate(%) in Low income in 2009?
Keep it short and to the point. 37.03. What is the difference between the Education completion rate(%) in Latin America(all income levels) in 2008 and the Education completion rate(%) in Cote d'Ivoire in 2009?
Offer a very short reply. 30.12. What is the difference between the Education completion rate(%) in Latin America(all income levels) in 2008 and the Education completion rate(%) in Seychelles in 2009?
Your response must be concise. -31.7. What is the difference between the Education completion rate(%) of Low income in 2008 and the Education completion rate(%) of Cote d'Ivoire in 2009?
Ensure brevity in your answer.  -8.46. What is the difference between the Education completion rate(%) in Low income in 2008 and the Education completion rate(%) in Seychelles in 2009?
Offer a terse response. -70.27. What is the difference between the Education completion rate(%) in Cote d'Ivoire in 2008 and the Education completion rate(%) in Seychelles in 2009?
Your answer should be compact. -57.34. What is the difference between the Education completion rate(%) of Latin America(all income levels) in 2008 and the Education completion rate(%) of Low income in 2011?
Your response must be concise. 35.03. What is the difference between the Education completion rate(%) in Latin America(all income levels) in 2008 and the Education completion rate(%) in Cote d'Ivoire in 2011?
Give a very brief answer. 36.56. What is the difference between the Education completion rate(%) in Latin America(all income levels) in 2008 and the Education completion rate(%) in Seychelles in 2011?
Offer a terse response. -31.79. What is the difference between the Education completion rate(%) of Low income in 2008 and the Education completion rate(%) of Cote d'Ivoire in 2011?
Offer a very short reply. -2.01. What is the difference between the Education completion rate(%) of Low income in 2008 and the Education completion rate(%) of Seychelles in 2011?
Your response must be concise. -70.36. What is the difference between the Education completion rate(%) of Cote d'Ivoire in 2008 and the Education completion rate(%) of Seychelles in 2011?
Keep it short and to the point. -57.43. What is the difference between the Education completion rate(%) in Latin America(all income levels) in 2009 and the Education completion rate(%) in Low income in 2011?
Ensure brevity in your answer.  36.19. What is the difference between the Education completion rate(%) of Latin America(all income levels) in 2009 and the Education completion rate(%) of Cote d'Ivoire in 2011?
Your answer should be very brief. 37.71. What is the difference between the Education completion rate(%) in Latin America(all income levels) in 2009 and the Education completion rate(%) in Seychelles in 2011?
Give a very brief answer. -30.63. What is the difference between the Education completion rate(%) of Low income in 2009 and the Education completion rate(%) of Cote d'Ivoire in 2011?
Provide a short and direct response. -0.47. What is the difference between the Education completion rate(%) in Low income in 2009 and the Education completion rate(%) in Seychelles in 2011?
Give a very brief answer. -68.82. What is the difference between the Education completion rate(%) of Cote d'Ivoire in 2009 and the Education completion rate(%) of Seychelles in 2011?
Give a very brief answer. -61.9. What is the average Education completion rate(%) in Latin America(all income levels) per year?
Provide a short and direct response. 69.89. What is the average Education completion rate(%) in Low income per year?
Make the answer very short. 30.34. What is the average Education completion rate(%) of Cote d'Ivoire per year?
Keep it short and to the point. 34.94. What is the average Education completion rate(%) of Seychelles per year?
Make the answer very short. 105.09. In the year 1998, what is the difference between the Education completion rate(%) in Latin America(all income levels) and Education completion rate(%) in Low income?
Make the answer very short. 40.74. In the year 1998, what is the difference between the Education completion rate(%) in Latin America(all income levels) and Education completion rate(%) in Cote d'Ivoire?
Keep it short and to the point. 34.28. In the year 1998, what is the difference between the Education completion rate(%) of Latin America(all income levels) and Education completion rate(%) of Seychelles?
Provide a succinct answer. -46.89. In the year 1998, what is the difference between the Education completion rate(%) of Low income and Education completion rate(%) of Cote d'Ivoire?
Keep it short and to the point. -6.46. In the year 1998, what is the difference between the Education completion rate(%) of Low income and Education completion rate(%) of Seychelles?
Offer a very short reply. -87.63. In the year 1998, what is the difference between the Education completion rate(%) in Cote d'Ivoire and Education completion rate(%) in Seychelles?
Make the answer very short. -81.16. In the year 2000, what is the difference between the Education completion rate(%) in Latin America(all income levels) and Education completion rate(%) in Low income?
Give a very brief answer. 41.38. In the year 2000, what is the difference between the Education completion rate(%) in Latin America(all income levels) and Education completion rate(%) in Cote d'Ivoire?
Keep it short and to the point. 43.75. In the year 2000, what is the difference between the Education completion rate(%) in Latin America(all income levels) and Education completion rate(%) in Seychelles?
Your answer should be compact. -41.56. In the year 2000, what is the difference between the Education completion rate(%) in Low income and Education completion rate(%) in Cote d'Ivoire?
Your answer should be compact. 2.37. In the year 2000, what is the difference between the Education completion rate(%) in Low income and Education completion rate(%) in Seychelles?
Provide a succinct answer. -82.94. In the year 2000, what is the difference between the Education completion rate(%) of Cote d'Ivoire and Education completion rate(%) of Seychelles?
Offer a very short reply. -85.31. In the year 2001, what is the difference between the Education completion rate(%) in Latin America(all income levels) and Education completion rate(%) in Low income?
Keep it short and to the point. 41.15. In the year 2001, what is the difference between the Education completion rate(%) in Latin America(all income levels) and Education completion rate(%) in Cote d'Ivoire?
Ensure brevity in your answer.  35.85. In the year 2001, what is the difference between the Education completion rate(%) of Latin America(all income levels) and Education completion rate(%) of Seychelles?
Your response must be concise. -27.35. In the year 2001, what is the difference between the Education completion rate(%) of Low income and Education completion rate(%) of Cote d'Ivoire?
Offer a terse response. -5.3. In the year 2001, what is the difference between the Education completion rate(%) in Low income and Education completion rate(%) in Seychelles?
Provide a succinct answer. -68.5. In the year 2001, what is the difference between the Education completion rate(%) in Cote d'Ivoire and Education completion rate(%) in Seychelles?
Provide a short and direct response. -63.2. In the year 2002, what is the difference between the Education completion rate(%) in Latin America(all income levels) and Education completion rate(%) in Low income?
Offer a very short reply. 41.58. In the year 2002, what is the difference between the Education completion rate(%) in Latin America(all income levels) and Education completion rate(%) in Cote d'Ivoire?
Provide a short and direct response. 34.89. In the year 2002, what is the difference between the Education completion rate(%) of Latin America(all income levels) and Education completion rate(%) of Seychelles?
Provide a succinct answer. -28.55. In the year 2002, what is the difference between the Education completion rate(%) in Low income and Education completion rate(%) in Cote d'Ivoire?
Provide a short and direct response. -6.7. In the year 2002, what is the difference between the Education completion rate(%) in Low income and Education completion rate(%) in Seychelles?
Ensure brevity in your answer.  -70.13. In the year 2002, what is the difference between the Education completion rate(%) of Cote d'Ivoire and Education completion rate(%) of Seychelles?
Provide a short and direct response. -63.44. In the year 2007, what is the difference between the Education completion rate(%) of Latin America(all income levels) and Education completion rate(%) of Low income?
Your answer should be compact. 39.59. In the year 2007, what is the difference between the Education completion rate(%) in Latin America(all income levels) and Education completion rate(%) in Cote d'Ivoire?
Your answer should be very brief. 37.25. In the year 2007, what is the difference between the Education completion rate(%) in Latin America(all income levels) and Education completion rate(%) in Seychelles?
Your answer should be compact. -38.81. In the year 2007, what is the difference between the Education completion rate(%) of Low income and Education completion rate(%) of Cote d'Ivoire?
Offer a terse response. -2.34. In the year 2007, what is the difference between the Education completion rate(%) in Low income and Education completion rate(%) in Seychelles?
Offer a very short reply. -78.39. In the year 2007, what is the difference between the Education completion rate(%) of Cote d'Ivoire and Education completion rate(%) of Seychelles?
Your answer should be compact. -76.05. In the year 2008, what is the difference between the Education completion rate(%) in Latin America(all income levels) and Education completion rate(%) in Low income?
Provide a succinct answer. 38.57. In the year 2008, what is the difference between the Education completion rate(%) of Latin America(all income levels) and Education completion rate(%) of Cote d'Ivoire?
Offer a very short reply. 25.64. In the year 2008, what is the difference between the Education completion rate(%) of Latin America(all income levels) and Education completion rate(%) of Seychelles?
Make the answer very short. -36.28. In the year 2008, what is the difference between the Education completion rate(%) of Low income and Education completion rate(%) of Cote d'Ivoire?
Provide a succinct answer. -12.93. In the year 2008, what is the difference between the Education completion rate(%) of Low income and Education completion rate(%) of Seychelles?
Offer a terse response. -74.85. In the year 2008, what is the difference between the Education completion rate(%) in Cote d'Ivoire and Education completion rate(%) in Seychelles?
Your response must be concise. -61.92. In the year 2009, what is the difference between the Education completion rate(%) of Latin America(all income levels) and Education completion rate(%) of Low income?
Your answer should be compact. 38.19. In the year 2009, what is the difference between the Education completion rate(%) in Latin America(all income levels) and Education completion rate(%) in Cote d'Ivoire?
Provide a succinct answer. 31.27. In the year 2009, what is the difference between the Education completion rate(%) in Latin America(all income levels) and Education completion rate(%) in Seychelles?
Your answer should be compact. -30.54. In the year 2009, what is the difference between the Education completion rate(%) of Low income and Education completion rate(%) of Cote d'Ivoire?
Your answer should be compact. -6.91. In the year 2009, what is the difference between the Education completion rate(%) in Low income and Education completion rate(%) in Seychelles?
Give a very brief answer. -68.73. In the year 2009, what is the difference between the Education completion rate(%) in Cote d'Ivoire and Education completion rate(%) in Seychelles?
Your answer should be very brief. -61.82. In the year 2011, what is the difference between the Education completion rate(%) in Latin America(all income levels) and Education completion rate(%) in Low income?
Your answer should be very brief. 35.21. In the year 2011, what is the difference between the Education completion rate(%) in Latin America(all income levels) and Education completion rate(%) in Cote d'Ivoire?
Keep it short and to the point. 36.73. In the year 2011, what is the difference between the Education completion rate(%) in Latin America(all income levels) and Education completion rate(%) in Seychelles?
Ensure brevity in your answer.  -31.61. In the year 2011, what is the difference between the Education completion rate(%) of Low income and Education completion rate(%) of Cote d'Ivoire?
Your answer should be very brief. 1.53. In the year 2011, what is the difference between the Education completion rate(%) in Low income and Education completion rate(%) in Seychelles?
Make the answer very short. -66.82. In the year 2011, what is the difference between the Education completion rate(%) in Cote d'Ivoire and Education completion rate(%) in Seychelles?
Your answer should be compact. -68.35. What is the ratio of the Education completion rate(%) of Latin America(all income levels) in 1998 to that in 2000?
Keep it short and to the point. 0.98. What is the ratio of the Education completion rate(%) in Low income in 1998 to that in 2000?
Give a very brief answer. 0.98. What is the ratio of the Education completion rate(%) of Cote d'Ivoire in 1998 to that in 2000?
Keep it short and to the point. 1.38. What is the ratio of the Education completion rate(%) of Seychelles in 1998 to that in 2000?
Offer a very short reply. 1.04. What is the ratio of the Education completion rate(%) of Latin America(all income levels) in 1998 to that in 2001?
Your answer should be very brief. 0.97. What is the ratio of the Education completion rate(%) of Low income in 1998 to that in 2001?
Your answer should be very brief. 0.94. What is the ratio of the Education completion rate(%) in Cote d'Ivoire in 1998 to that in 2001?
Offer a very short reply. 0.99. What is the ratio of the Education completion rate(%) of Seychelles in 1998 to that in 2001?
Your response must be concise. 1.19. What is the ratio of the Education completion rate(%) in Latin America(all income levels) in 1998 to that in 2002?
Keep it short and to the point. 0.95. What is the ratio of the Education completion rate(%) of Low income in 1998 to that in 2002?
Give a very brief answer. 0.9. What is the ratio of the Education completion rate(%) of Cote d'Ivoire in 1998 to that in 2002?
Provide a short and direct response. 0.91. What is the ratio of the Education completion rate(%) of Seychelles in 1998 to that in 2002?
Your answer should be very brief. 1.15. What is the ratio of the Education completion rate(%) in Latin America(all income levels) in 1998 to that in 2007?
Provide a succinct answer. 0.88. What is the ratio of the Education completion rate(%) of Low income in 1998 to that in 2007?
Offer a very short reply. 0.71. What is the ratio of the Education completion rate(%) in Cote d'Ivoire in 1998 to that in 2007?
Give a very brief answer. 0.85. What is the ratio of the Education completion rate(%) of Latin America(all income levels) in 1998 to that in 2008?
Make the answer very short. 0.87. What is the ratio of the Education completion rate(%) in Low income in 1998 to that in 2008?
Your answer should be very brief. 0.67. What is the ratio of the Education completion rate(%) of Cote d'Ivoire in 1998 to that in 2008?
Give a very brief answer. 0.63. What is the ratio of the Education completion rate(%) of Seychelles in 1998 to that in 2008?
Provide a succinct answer. 1.01. What is the ratio of the Education completion rate(%) of Latin America(all income levels) in 1998 to that in 2009?
Make the answer very short. 0.86. What is the ratio of the Education completion rate(%) of Low income in 1998 to that in 2009?
Offer a very short reply. 0.64. What is the ratio of the Education completion rate(%) of Cote d'Ivoire in 1998 to that in 2009?
Ensure brevity in your answer.  0.69. What is the ratio of the Education completion rate(%) of Seychelles in 1998 to that in 2009?
Provide a succinct answer. 1.06. What is the ratio of the Education completion rate(%) of Latin America(all income levels) in 1998 to that in 2011?
Provide a succinct answer. 0.87. What is the ratio of the Education completion rate(%) in Low income in 1998 to that in 2011?
Keep it short and to the point. 0.61. What is the ratio of the Education completion rate(%) in Cote d'Ivoire in 1998 to that in 2011?
Make the answer very short. 0.81. What is the ratio of the Education completion rate(%) of Seychelles in 1998 to that in 2011?
Make the answer very short. 1.05. What is the ratio of the Education completion rate(%) in Latin America(all income levels) in 2000 to that in 2001?
Provide a short and direct response. 0.99. What is the ratio of the Education completion rate(%) in Low income in 2000 to that in 2001?
Provide a short and direct response. 0.97. What is the ratio of the Education completion rate(%) in Cote d'Ivoire in 2000 to that in 2001?
Your answer should be compact. 0.72. What is the ratio of the Education completion rate(%) of Seychelles in 2000 to that in 2001?
Keep it short and to the point. 1.15. What is the ratio of the Education completion rate(%) in Latin America(all income levels) in 2000 to that in 2002?
Offer a very short reply. 0.97. What is the ratio of the Education completion rate(%) in Low income in 2000 to that in 2002?
Make the answer very short. 0.92. What is the ratio of the Education completion rate(%) of Cote d'Ivoire in 2000 to that in 2002?
Offer a terse response. 0.66. What is the ratio of the Education completion rate(%) of Seychelles in 2000 to that in 2002?
Your response must be concise. 1.11. What is the ratio of the Education completion rate(%) in Latin America(all income levels) in 2000 to that in 2007?
Ensure brevity in your answer.  0.9. What is the ratio of the Education completion rate(%) in Low income in 2000 to that in 2007?
Provide a succinct answer. 0.73. What is the ratio of the Education completion rate(%) in Cote d'Ivoire in 2000 to that in 2007?
Your response must be concise. 0.61. What is the ratio of the Education completion rate(%) of Seychelles in 2000 to that in 2007?
Make the answer very short. 0.96. What is the ratio of the Education completion rate(%) of Latin America(all income levels) in 2000 to that in 2008?
Offer a very short reply. 0.89. What is the ratio of the Education completion rate(%) of Low income in 2000 to that in 2008?
Ensure brevity in your answer.  0.69. What is the ratio of the Education completion rate(%) in Cote d'Ivoire in 2000 to that in 2008?
Offer a terse response. 0.45. What is the ratio of the Education completion rate(%) of Seychelles in 2000 to that in 2008?
Offer a terse response. 0.97. What is the ratio of the Education completion rate(%) of Latin America(all income levels) in 2000 to that in 2009?
Provide a short and direct response. 0.88. What is the ratio of the Education completion rate(%) of Low income in 2000 to that in 2009?
Keep it short and to the point. 0.66. What is the ratio of the Education completion rate(%) in Cote d'Ivoire in 2000 to that in 2009?
Make the answer very short. 0.5. What is the ratio of the Education completion rate(%) in Seychelles in 2000 to that in 2009?
Give a very brief answer. 1.02. What is the ratio of the Education completion rate(%) in Latin America(all income levels) in 2000 to that in 2011?
Your response must be concise. 0.89. What is the ratio of the Education completion rate(%) in Low income in 2000 to that in 2011?
Provide a short and direct response. 0.63. What is the ratio of the Education completion rate(%) in Cote d'Ivoire in 2000 to that in 2011?
Make the answer very short. 0.59. What is the ratio of the Education completion rate(%) in Seychelles in 2000 to that in 2011?
Your response must be concise. 1.02. What is the ratio of the Education completion rate(%) of Latin America(all income levels) in 2001 to that in 2002?
Your answer should be very brief. 0.98. What is the ratio of the Education completion rate(%) in Low income in 2001 to that in 2002?
Make the answer very short. 0.95. What is the ratio of the Education completion rate(%) of Cote d'Ivoire in 2001 to that in 2002?
Offer a terse response. 0.92. What is the ratio of the Education completion rate(%) of Seychelles in 2001 to that in 2002?
Your response must be concise. 0.97. What is the ratio of the Education completion rate(%) of Latin America(all income levels) in 2001 to that in 2007?
Provide a short and direct response. 0.91. What is the ratio of the Education completion rate(%) of Low income in 2001 to that in 2007?
Offer a terse response. 0.75. What is the ratio of the Education completion rate(%) in Cote d'Ivoire in 2001 to that in 2007?
Offer a terse response. 0.85. What is the ratio of the Education completion rate(%) of Seychelles in 2001 to that in 2007?
Offer a terse response. 0.84. What is the ratio of the Education completion rate(%) of Latin America(all income levels) in 2001 to that in 2008?
Give a very brief answer. 0.9. What is the ratio of the Education completion rate(%) in Low income in 2001 to that in 2008?
Ensure brevity in your answer.  0.71. What is the ratio of the Education completion rate(%) in Cote d'Ivoire in 2001 to that in 2008?
Your answer should be compact. 0.63. What is the ratio of the Education completion rate(%) of Seychelles in 2001 to that in 2008?
Ensure brevity in your answer.  0.85. What is the ratio of the Education completion rate(%) in Latin America(all income levels) in 2001 to that in 2009?
Your answer should be very brief. 0.88. What is the ratio of the Education completion rate(%) in Low income in 2001 to that in 2009?
Offer a very short reply. 0.68. What is the ratio of the Education completion rate(%) in Cote d'Ivoire in 2001 to that in 2009?
Provide a short and direct response. 0.7. What is the ratio of the Education completion rate(%) of Seychelles in 2001 to that in 2009?
Your answer should be very brief. 0.89. What is the ratio of the Education completion rate(%) in Latin America(all income levels) in 2001 to that in 2011?
Keep it short and to the point. 0.9. What is the ratio of the Education completion rate(%) in Low income in 2001 to that in 2011?
Provide a short and direct response. 0.65. What is the ratio of the Education completion rate(%) in Cote d'Ivoire in 2001 to that in 2011?
Provide a succinct answer. 0.82. What is the ratio of the Education completion rate(%) in Seychelles in 2001 to that in 2011?
Give a very brief answer. 0.89. What is the ratio of the Education completion rate(%) of Latin America(all income levels) in 2002 to that in 2007?
Offer a very short reply. 0.93. What is the ratio of the Education completion rate(%) in Low income in 2002 to that in 2007?
Make the answer very short. 0.79. What is the ratio of the Education completion rate(%) in Cote d'Ivoire in 2002 to that in 2007?
Your answer should be compact. 0.93. What is the ratio of the Education completion rate(%) of Seychelles in 2002 to that in 2007?
Make the answer very short. 0.86. What is the ratio of the Education completion rate(%) of Latin America(all income levels) in 2002 to that in 2008?
Keep it short and to the point. 0.92. What is the ratio of the Education completion rate(%) of Low income in 2002 to that in 2008?
Offer a terse response. 0.75. What is the ratio of the Education completion rate(%) of Cote d'Ivoire in 2002 to that in 2008?
Provide a short and direct response. 0.69. What is the ratio of the Education completion rate(%) of Seychelles in 2002 to that in 2008?
Your answer should be very brief. 0.88. What is the ratio of the Education completion rate(%) in Latin America(all income levels) in 2002 to that in 2009?
Offer a very short reply. 0.91. What is the ratio of the Education completion rate(%) in Low income in 2002 to that in 2009?
Your answer should be compact. 0.72. What is the ratio of the Education completion rate(%) of Cote d'Ivoire in 2002 to that in 2009?
Provide a short and direct response. 0.76. What is the ratio of the Education completion rate(%) in Seychelles in 2002 to that in 2009?
Your answer should be compact. 0.91. What is the ratio of the Education completion rate(%) of Latin America(all income levels) in 2002 to that in 2011?
Offer a very short reply. 0.92. What is the ratio of the Education completion rate(%) of Low income in 2002 to that in 2011?
Ensure brevity in your answer.  0.68. What is the ratio of the Education completion rate(%) in Cote d'Ivoire in 2002 to that in 2011?
Ensure brevity in your answer.  0.89. What is the ratio of the Education completion rate(%) of Seychelles in 2002 to that in 2011?
Your answer should be very brief. 0.91. What is the ratio of the Education completion rate(%) in Low income in 2007 to that in 2008?
Your answer should be compact. 0.95. What is the ratio of the Education completion rate(%) of Cote d'Ivoire in 2007 to that in 2008?
Keep it short and to the point. 0.74. What is the ratio of the Education completion rate(%) of Latin America(all income levels) in 2007 to that in 2009?
Your answer should be compact. 0.97. What is the ratio of the Education completion rate(%) in Low income in 2007 to that in 2009?
Your answer should be very brief. 0.91. What is the ratio of the Education completion rate(%) in Cote d'Ivoire in 2007 to that in 2009?
Make the answer very short. 0.82. What is the ratio of the Education completion rate(%) of Seychelles in 2007 to that in 2009?
Your response must be concise. 1.06. What is the ratio of the Education completion rate(%) in Latin America(all income levels) in 2007 to that in 2011?
Your answer should be compact. 0.99. What is the ratio of the Education completion rate(%) of Low income in 2007 to that in 2011?
Your answer should be compact. 0.86. What is the ratio of the Education completion rate(%) of Cote d'Ivoire in 2007 to that in 2011?
Provide a short and direct response. 0.96. What is the ratio of the Education completion rate(%) in Seychelles in 2007 to that in 2011?
Give a very brief answer. 1.06. What is the ratio of the Education completion rate(%) in Latin America(all income levels) in 2008 to that in 2009?
Offer a very short reply. 0.98. What is the ratio of the Education completion rate(%) in Low income in 2008 to that in 2009?
Your answer should be compact. 0.96. What is the ratio of the Education completion rate(%) in Cote d'Ivoire in 2008 to that in 2009?
Keep it short and to the point. 1.1. What is the ratio of the Education completion rate(%) of Seychelles in 2008 to that in 2009?
Keep it short and to the point. 1.04. What is the ratio of the Education completion rate(%) of Latin America(all income levels) in 2008 to that in 2011?
Your answer should be compact. 1. What is the ratio of the Education completion rate(%) of Low income in 2008 to that in 2011?
Give a very brief answer. 0.91. What is the ratio of the Education completion rate(%) of Cote d'Ivoire in 2008 to that in 2011?
Your response must be concise. 1.29. What is the ratio of the Education completion rate(%) in Seychelles in 2008 to that in 2011?
Provide a succinct answer. 1.04. What is the ratio of the Education completion rate(%) in Latin America(all income levels) in 2009 to that in 2011?
Ensure brevity in your answer.  1.01. What is the ratio of the Education completion rate(%) in Low income in 2009 to that in 2011?
Offer a very short reply. 0.95. What is the ratio of the Education completion rate(%) in Cote d'Ivoire in 2009 to that in 2011?
Ensure brevity in your answer.  1.17. What is the difference between the highest and the second highest Education completion rate(%) in Latin America(all income levels)?
Offer a very short reply. 0.98. What is the difference between the highest and the second highest Education completion rate(%) in Low income?
Offer a very short reply. 2. What is the difference between the highest and the second highest Education completion rate(%) of Cote d'Ivoire?
Ensure brevity in your answer.  4.48. What is the difference between the highest and the second highest Education completion rate(%) in Seychelles?
Keep it short and to the point. 0.38. What is the difference between the highest and the lowest Education completion rate(%) in Latin America(all income levels)?
Offer a terse response. 10.49. What is the difference between the highest and the lowest Education completion rate(%) of Low income?
Offer a very short reply. 15.05. What is the difference between the highest and the lowest Education completion rate(%) of Cote d'Ivoire?
Keep it short and to the point. 26.24. What is the difference between the highest and the lowest Education completion rate(%) of Seychelles?
Your response must be concise. 18.11. 